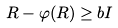<formula> <loc_0><loc_0><loc_500><loc_500>R - \varphi ( R ) \geq b I</formula> 